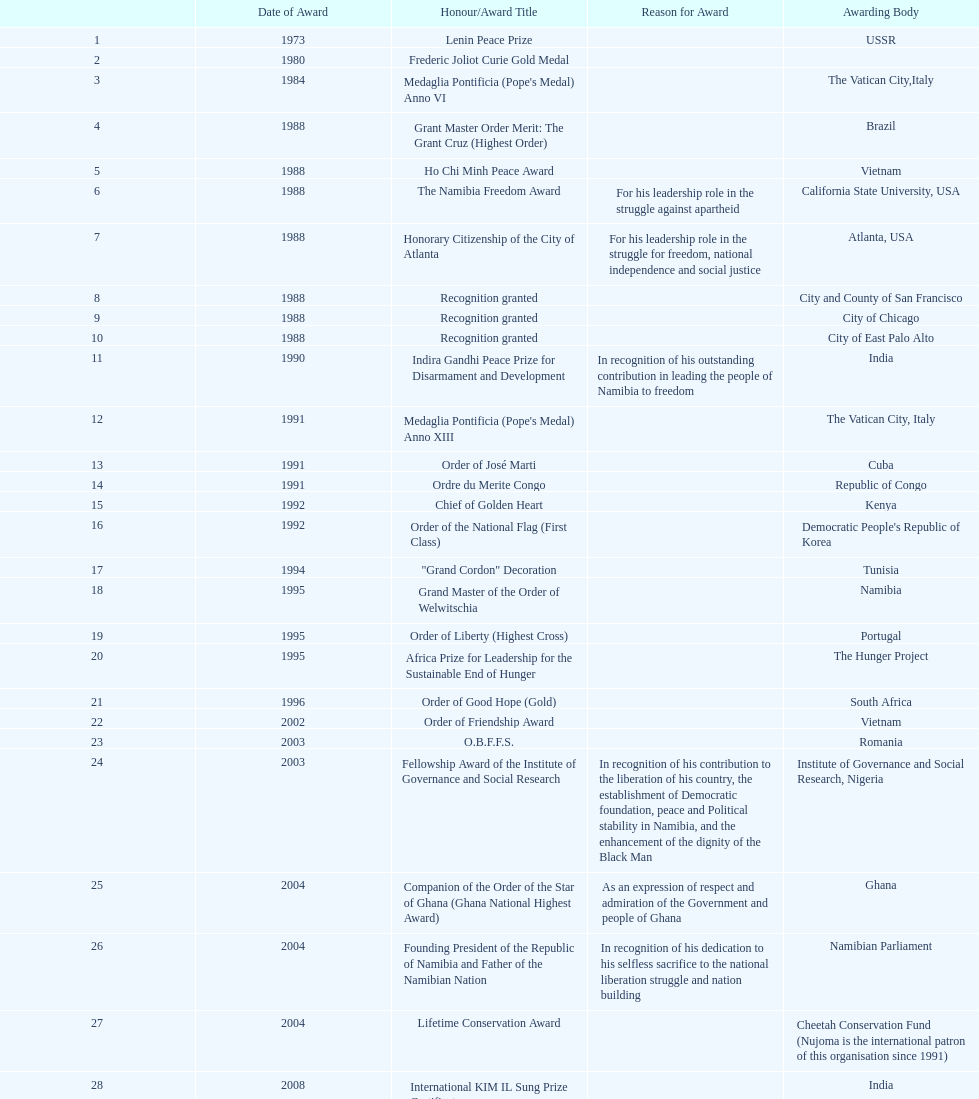What award was won previously just before the medaglia pontificia anno xiii was awarded? Indira Gandhi Peace Prize for Disarmament and Development. 